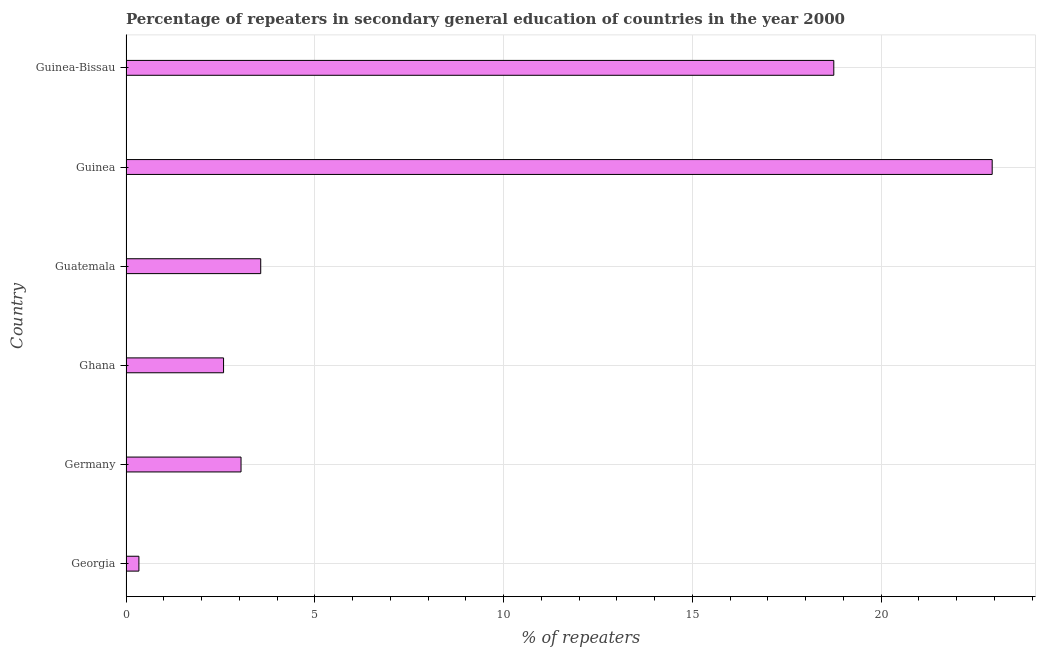Does the graph contain any zero values?
Make the answer very short. No. What is the title of the graph?
Offer a very short reply. Percentage of repeaters in secondary general education of countries in the year 2000. What is the label or title of the X-axis?
Provide a short and direct response. % of repeaters. What is the percentage of repeaters in Ghana?
Offer a terse response. 2.58. Across all countries, what is the maximum percentage of repeaters?
Give a very brief answer. 22.94. Across all countries, what is the minimum percentage of repeaters?
Offer a very short reply. 0.34. In which country was the percentage of repeaters maximum?
Provide a short and direct response. Guinea. In which country was the percentage of repeaters minimum?
Give a very brief answer. Georgia. What is the sum of the percentage of repeaters?
Make the answer very short. 51.23. What is the difference between the percentage of repeaters in Georgia and Guinea-Bissau?
Ensure brevity in your answer.  -18.41. What is the average percentage of repeaters per country?
Give a very brief answer. 8.54. What is the median percentage of repeaters?
Make the answer very short. 3.31. In how many countries, is the percentage of repeaters greater than 14 %?
Provide a succinct answer. 2. What is the ratio of the percentage of repeaters in Guatemala to that in Guinea-Bissau?
Give a very brief answer. 0.19. Is the percentage of repeaters in Georgia less than that in Germany?
Provide a succinct answer. Yes. What is the difference between the highest and the second highest percentage of repeaters?
Give a very brief answer. 4.2. What is the difference between the highest and the lowest percentage of repeaters?
Your answer should be compact. 22.6. How many bars are there?
Give a very brief answer. 6. How many countries are there in the graph?
Offer a terse response. 6. What is the difference between two consecutive major ticks on the X-axis?
Keep it short and to the point. 5. Are the values on the major ticks of X-axis written in scientific E-notation?
Keep it short and to the point. No. What is the % of repeaters of Georgia?
Provide a succinct answer. 0.34. What is the % of repeaters of Germany?
Keep it short and to the point. 3.05. What is the % of repeaters in Ghana?
Ensure brevity in your answer.  2.58. What is the % of repeaters of Guatemala?
Your answer should be very brief. 3.57. What is the % of repeaters of Guinea?
Provide a succinct answer. 22.94. What is the % of repeaters of Guinea-Bissau?
Your answer should be very brief. 18.75. What is the difference between the % of repeaters in Georgia and Germany?
Offer a terse response. -2.71. What is the difference between the % of repeaters in Georgia and Ghana?
Provide a succinct answer. -2.24. What is the difference between the % of repeaters in Georgia and Guatemala?
Give a very brief answer. -3.23. What is the difference between the % of repeaters in Georgia and Guinea?
Provide a succinct answer. -22.6. What is the difference between the % of repeaters in Georgia and Guinea-Bissau?
Provide a short and direct response. -18.41. What is the difference between the % of repeaters in Germany and Ghana?
Offer a very short reply. 0.46. What is the difference between the % of repeaters in Germany and Guatemala?
Your answer should be very brief. -0.52. What is the difference between the % of repeaters in Germany and Guinea?
Your response must be concise. -19.9. What is the difference between the % of repeaters in Germany and Guinea-Bissau?
Provide a succinct answer. -15.7. What is the difference between the % of repeaters in Ghana and Guatemala?
Ensure brevity in your answer.  -0.98. What is the difference between the % of repeaters in Ghana and Guinea?
Your answer should be compact. -20.36. What is the difference between the % of repeaters in Ghana and Guinea-Bissau?
Keep it short and to the point. -16.16. What is the difference between the % of repeaters in Guatemala and Guinea?
Offer a terse response. -19.37. What is the difference between the % of repeaters in Guatemala and Guinea-Bissau?
Keep it short and to the point. -15.18. What is the difference between the % of repeaters in Guinea and Guinea-Bissau?
Provide a short and direct response. 4.19. What is the ratio of the % of repeaters in Georgia to that in Germany?
Offer a terse response. 0.11. What is the ratio of the % of repeaters in Georgia to that in Ghana?
Make the answer very short. 0.13. What is the ratio of the % of repeaters in Georgia to that in Guatemala?
Offer a very short reply. 0.1. What is the ratio of the % of repeaters in Georgia to that in Guinea?
Your answer should be compact. 0.01. What is the ratio of the % of repeaters in Georgia to that in Guinea-Bissau?
Provide a short and direct response. 0.02. What is the ratio of the % of repeaters in Germany to that in Ghana?
Your answer should be compact. 1.18. What is the ratio of the % of repeaters in Germany to that in Guatemala?
Provide a short and direct response. 0.85. What is the ratio of the % of repeaters in Germany to that in Guinea?
Ensure brevity in your answer.  0.13. What is the ratio of the % of repeaters in Germany to that in Guinea-Bissau?
Ensure brevity in your answer.  0.16. What is the ratio of the % of repeaters in Ghana to that in Guatemala?
Offer a very short reply. 0.72. What is the ratio of the % of repeaters in Ghana to that in Guinea?
Make the answer very short. 0.11. What is the ratio of the % of repeaters in Ghana to that in Guinea-Bissau?
Make the answer very short. 0.14. What is the ratio of the % of repeaters in Guatemala to that in Guinea?
Your response must be concise. 0.16. What is the ratio of the % of repeaters in Guatemala to that in Guinea-Bissau?
Your answer should be compact. 0.19. What is the ratio of the % of repeaters in Guinea to that in Guinea-Bissau?
Your answer should be compact. 1.22. 